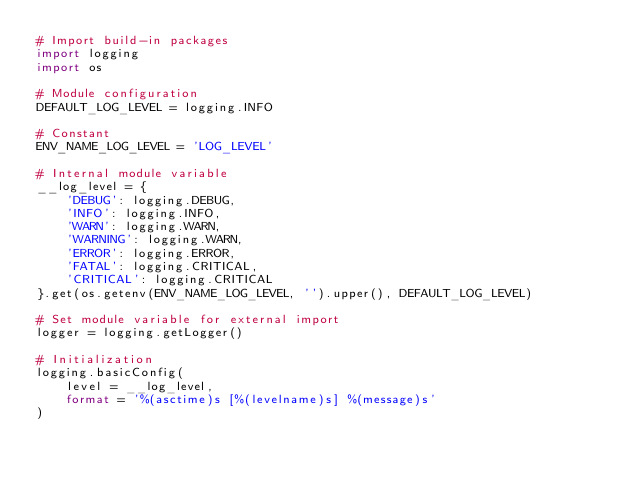Convert code to text. <code><loc_0><loc_0><loc_500><loc_500><_Python_># Import build-in packages
import logging
import os

# Module configuration
DEFAULT_LOG_LEVEL = logging.INFO

# Constant
ENV_NAME_LOG_LEVEL = 'LOG_LEVEL'

# Internal module variable
__log_level = {
    'DEBUG': logging.DEBUG,
    'INFO': logging.INFO,
    'WARN': logging.WARN,
    'WARNING': logging.WARN,
    'ERROR': logging.ERROR,
    'FATAL': logging.CRITICAL,
    'CRITICAL': logging.CRITICAL
}.get(os.getenv(ENV_NAME_LOG_LEVEL, '').upper(), DEFAULT_LOG_LEVEL)

# Set module variable for external import
logger = logging.getLogger()

# Initialization
logging.basicConfig(
    level = __log_level,
    format = '%(asctime)s [%(levelname)s] %(message)s'
)
</code> 